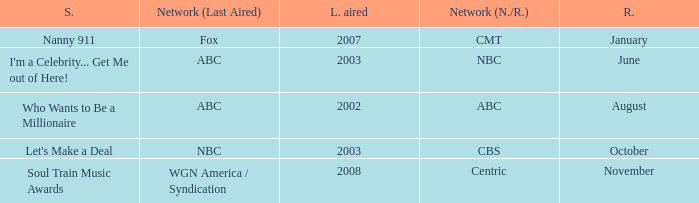When did a show last aired in 2002 return? August. 